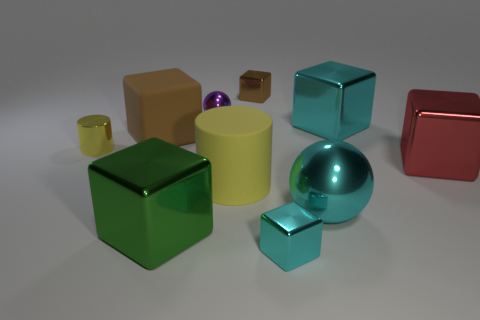There is a small object that is the same color as the rubber cube; what is its shape?
Provide a short and direct response. Cube. What number of shiny things are both to the right of the big cyan metallic sphere and behind the tiny metallic sphere?
Give a very brief answer. 0. What material is the large red object?
Your answer should be compact. Metal. How many things are large cyan blocks or brown things?
Your response must be concise. 3. Is the size of the green shiny thing that is in front of the brown rubber cube the same as the yellow cylinder that is behind the large red metallic block?
Your answer should be very brief. No. How many other objects are the same size as the red thing?
Provide a succinct answer. 5. What number of things are metal blocks left of the big cylinder or cyan metallic blocks in front of the red metal thing?
Keep it short and to the point. 2. Are the large cyan block and the yellow thing that is on the left side of the purple metal object made of the same material?
Your answer should be very brief. Yes. How many other objects are the same shape as the red thing?
Provide a short and direct response. 5. What material is the small purple thing that is to the right of the large object that is in front of the large cyan sphere in front of the red shiny thing made of?
Keep it short and to the point. Metal. 